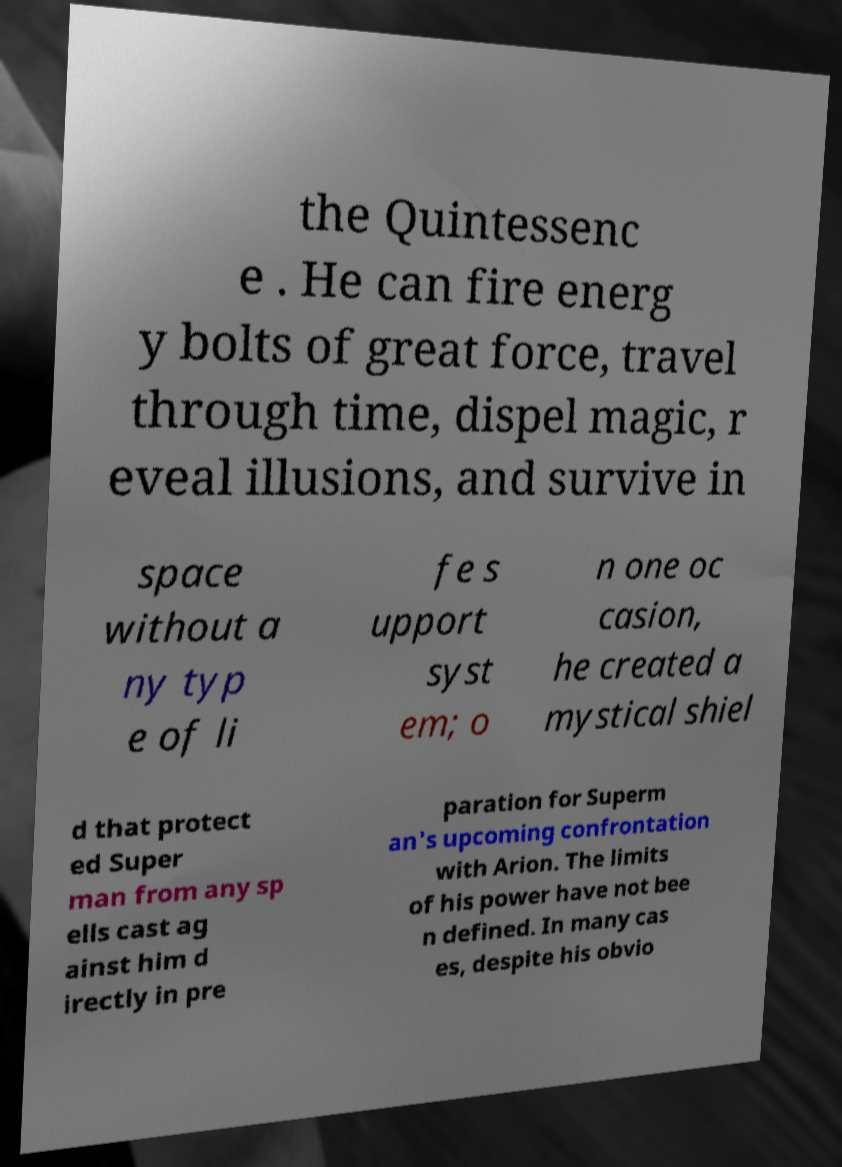There's text embedded in this image that I need extracted. Can you transcribe it verbatim? the Quintessenc e . He can fire energ y bolts of great force, travel through time, dispel magic, r eveal illusions, and survive in space without a ny typ e of li fe s upport syst em; o n one oc casion, he created a mystical shiel d that protect ed Super man from any sp ells cast ag ainst him d irectly in pre paration for Superm an's upcoming confrontation with Arion. The limits of his power have not bee n defined. In many cas es, despite his obvio 